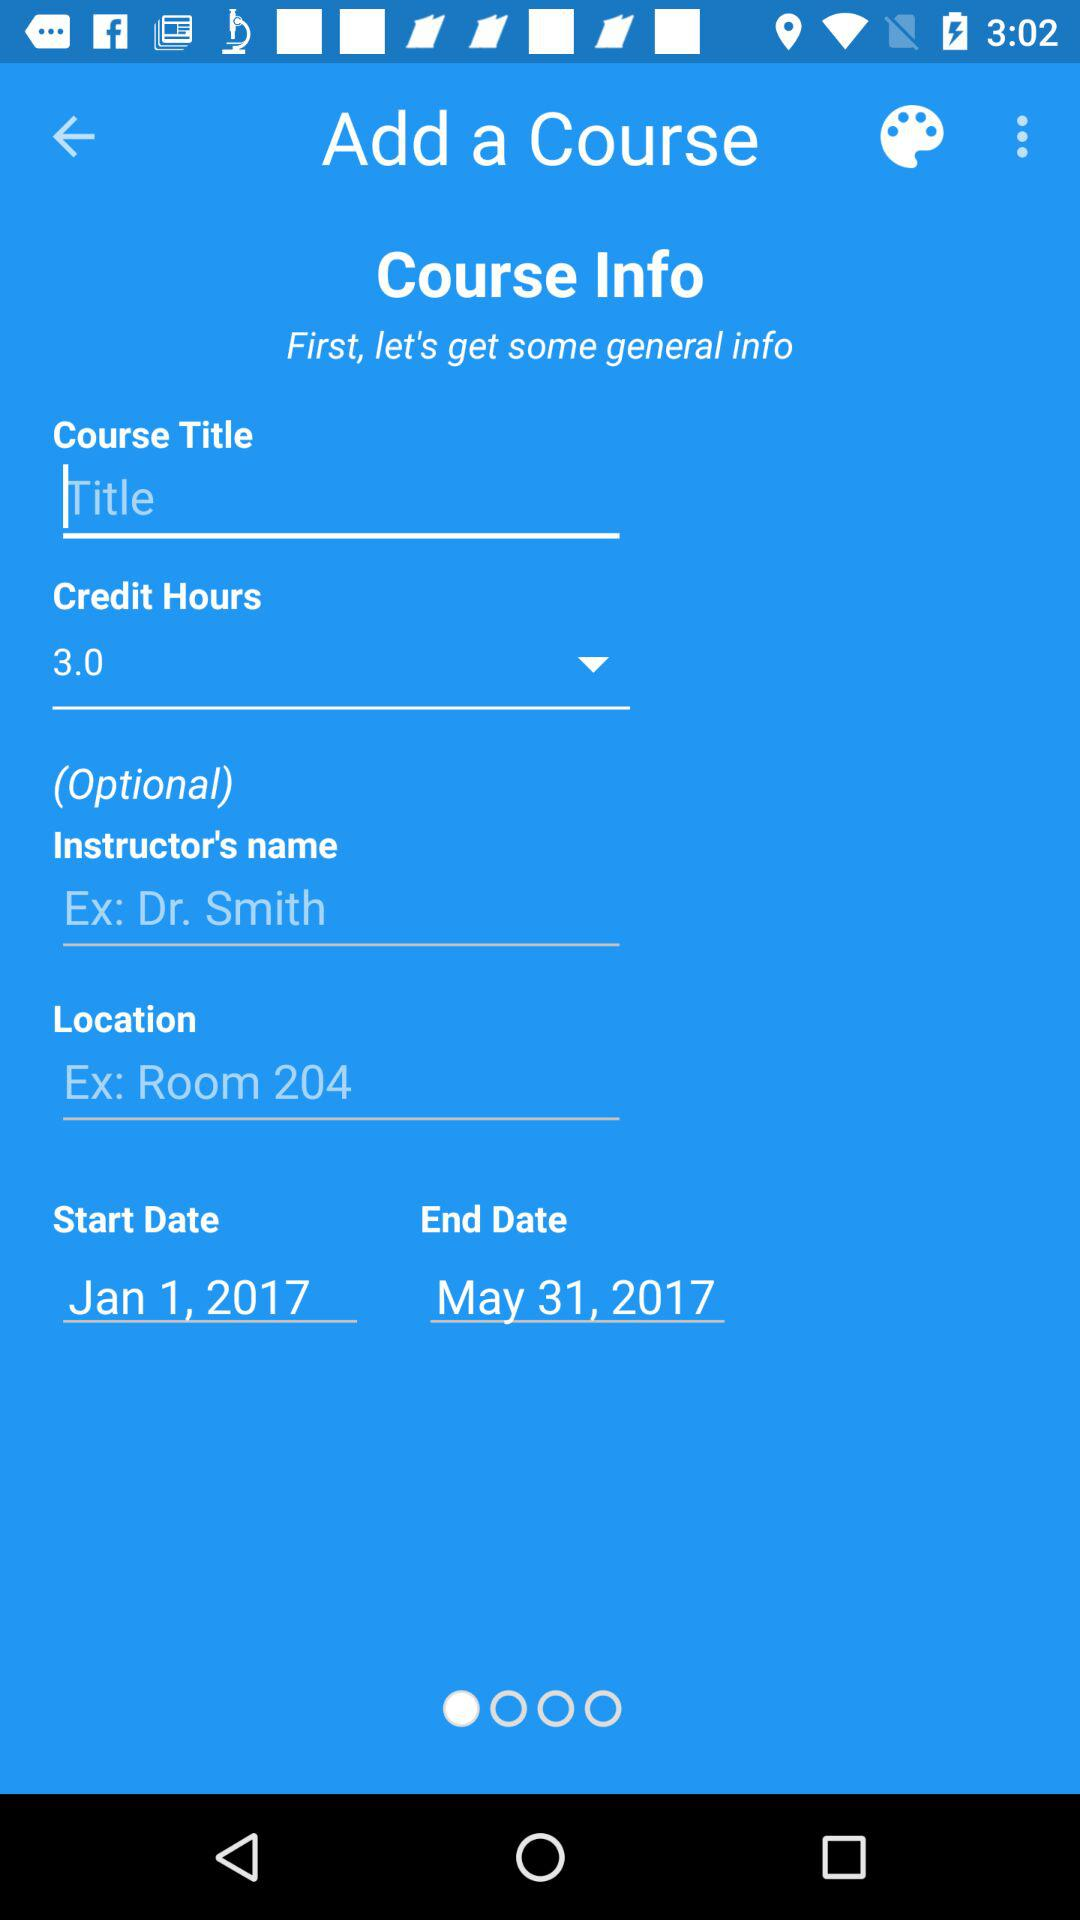What is the course start date? The start date is January 1, 2017. 